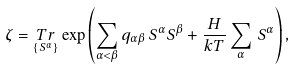Convert formula to latex. <formula><loc_0><loc_0><loc_500><loc_500>\zeta = \underset { \{ S ^ { \alpha } \} } { T r } \exp \left ( \sum _ { \alpha < \beta } q _ { \alpha \beta } \, S ^ { \alpha } S ^ { \beta } + \frac { H } { k T } \sum _ { \alpha } \, S ^ { \alpha } \right ) ,</formula> 